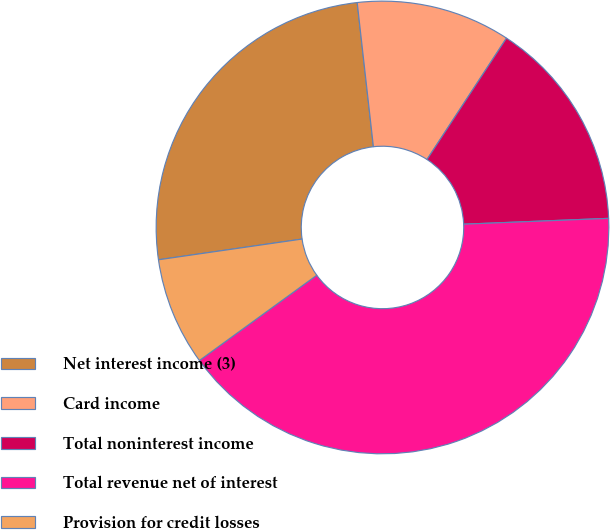<chart> <loc_0><loc_0><loc_500><loc_500><pie_chart><fcel>Net interest income (3)<fcel>Card income<fcel>Total noninterest income<fcel>Total revenue net of interest<fcel>Provision for credit losses<nl><fcel>25.5%<fcel>11.01%<fcel>15.13%<fcel>40.64%<fcel>7.72%<nl></chart> 